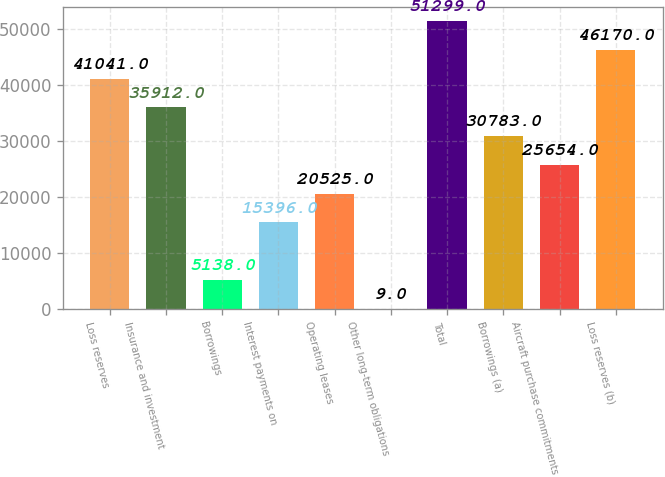Convert chart. <chart><loc_0><loc_0><loc_500><loc_500><bar_chart><fcel>Loss reserves<fcel>Insurance and investment<fcel>Borrowings<fcel>Interest payments on<fcel>Operating leases<fcel>Other long-term obligations<fcel>Total<fcel>Borrowings (a)<fcel>Aircraft purchase commitments<fcel>Loss reserves (b)<nl><fcel>41041<fcel>35912<fcel>5138<fcel>15396<fcel>20525<fcel>9<fcel>51299<fcel>30783<fcel>25654<fcel>46170<nl></chart> 